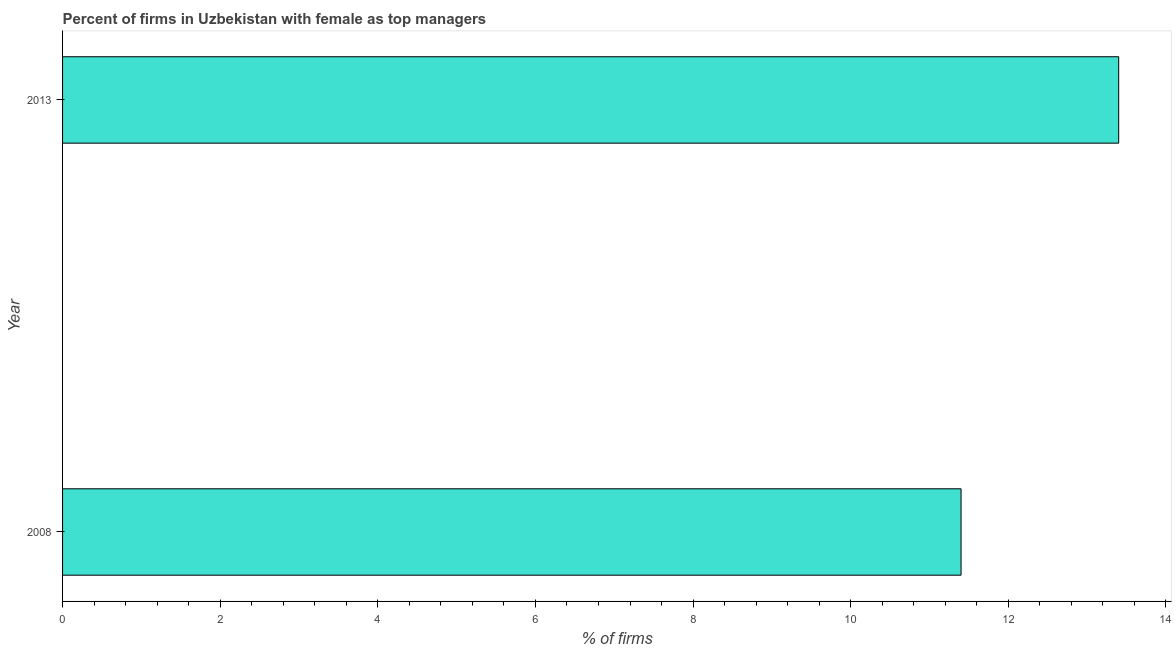Does the graph contain any zero values?
Ensure brevity in your answer.  No. Does the graph contain grids?
Provide a succinct answer. No. What is the title of the graph?
Provide a succinct answer. Percent of firms in Uzbekistan with female as top managers. What is the label or title of the X-axis?
Ensure brevity in your answer.  % of firms. What is the percentage of firms with female as top manager in 2013?
Your answer should be compact. 13.4. What is the sum of the percentage of firms with female as top manager?
Your response must be concise. 24.8. What is the average percentage of firms with female as top manager per year?
Provide a succinct answer. 12.4. What is the ratio of the percentage of firms with female as top manager in 2008 to that in 2013?
Provide a short and direct response. 0.85. In how many years, is the percentage of firms with female as top manager greater than the average percentage of firms with female as top manager taken over all years?
Your response must be concise. 1. What is the % of firms of 2008?
Your response must be concise. 11.4. What is the % of firms of 2013?
Provide a short and direct response. 13.4. What is the difference between the % of firms in 2008 and 2013?
Make the answer very short. -2. What is the ratio of the % of firms in 2008 to that in 2013?
Provide a short and direct response. 0.85. 